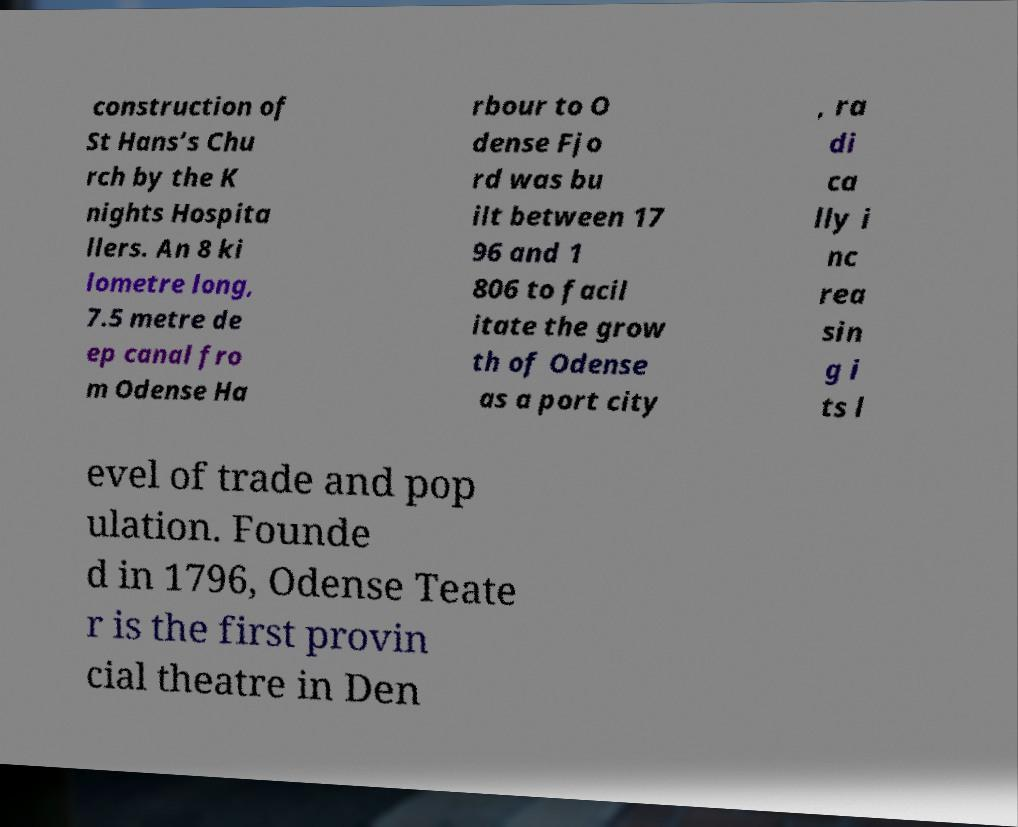I need the written content from this picture converted into text. Can you do that? construction of St Hans’s Chu rch by the K nights Hospita llers. An 8 ki lometre long, 7.5 metre de ep canal fro m Odense Ha rbour to O dense Fjo rd was bu ilt between 17 96 and 1 806 to facil itate the grow th of Odense as a port city , ra di ca lly i nc rea sin g i ts l evel of trade and pop ulation. Founde d in 1796, Odense Teate r is the first provin cial theatre in Den 